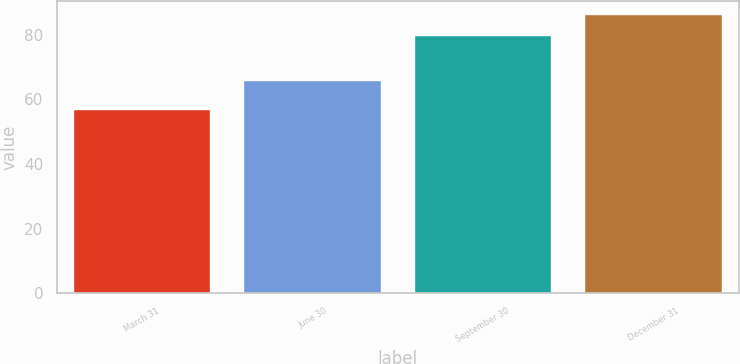Convert chart to OTSL. <chart><loc_0><loc_0><loc_500><loc_500><bar_chart><fcel>March 31<fcel>June 30<fcel>September 30<fcel>December 31<nl><fcel>56.84<fcel>65.59<fcel>79.54<fcel>86.06<nl></chart> 